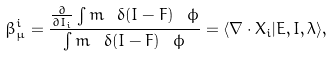Convert formula to latex. <formula><loc_0><loc_0><loc_500><loc_500>\beta ^ { i } _ { \mu } = \frac { \frac { \partial } { \partial I _ { i } } \int m \ \delta ( I - F ) \ \phi } { \int m \ \delta ( I - F ) \ \phi } = \langle \nabla \cdot X _ { i } | E , I , \lambda \rangle ,</formula> 